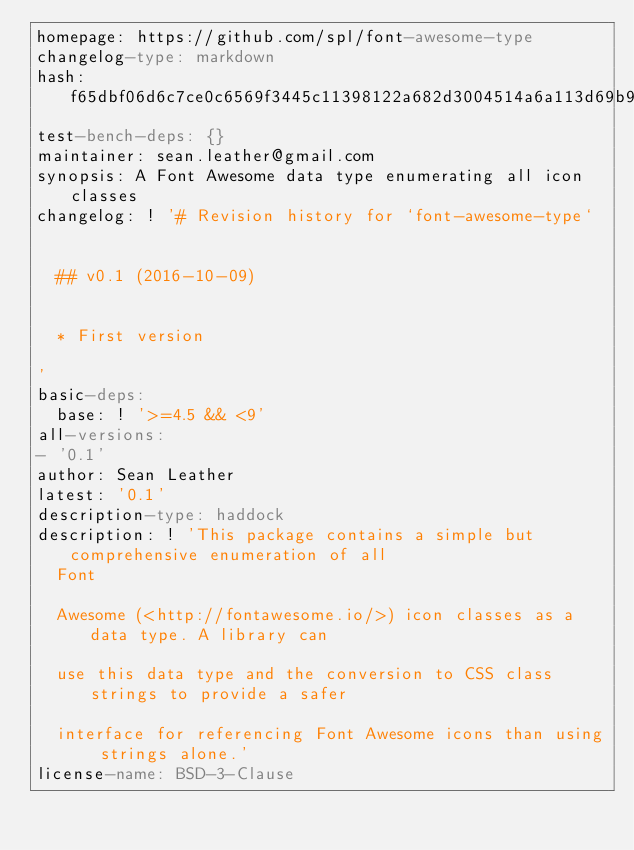Convert code to text. <code><loc_0><loc_0><loc_500><loc_500><_YAML_>homepage: https://github.com/spl/font-awesome-type
changelog-type: markdown
hash: f65dbf06d6c7ce0c6569f3445c11398122a682d3004514a6a113d69b96e878b0
test-bench-deps: {}
maintainer: sean.leather@gmail.com
synopsis: A Font Awesome data type enumerating all icon classes
changelog: ! '# Revision history for `font-awesome-type`


  ## v0.1 (2016-10-09)


  * First version

'
basic-deps:
  base: ! '>=4.5 && <9'
all-versions:
- '0.1'
author: Sean Leather
latest: '0.1'
description-type: haddock
description: ! 'This package contains a simple but comprehensive enumeration of all
  Font

  Awesome (<http://fontawesome.io/>) icon classes as a data type. A library can

  use this data type and the conversion to CSS class strings to provide a safer

  interface for referencing Font Awesome icons than using strings alone.'
license-name: BSD-3-Clause
</code> 